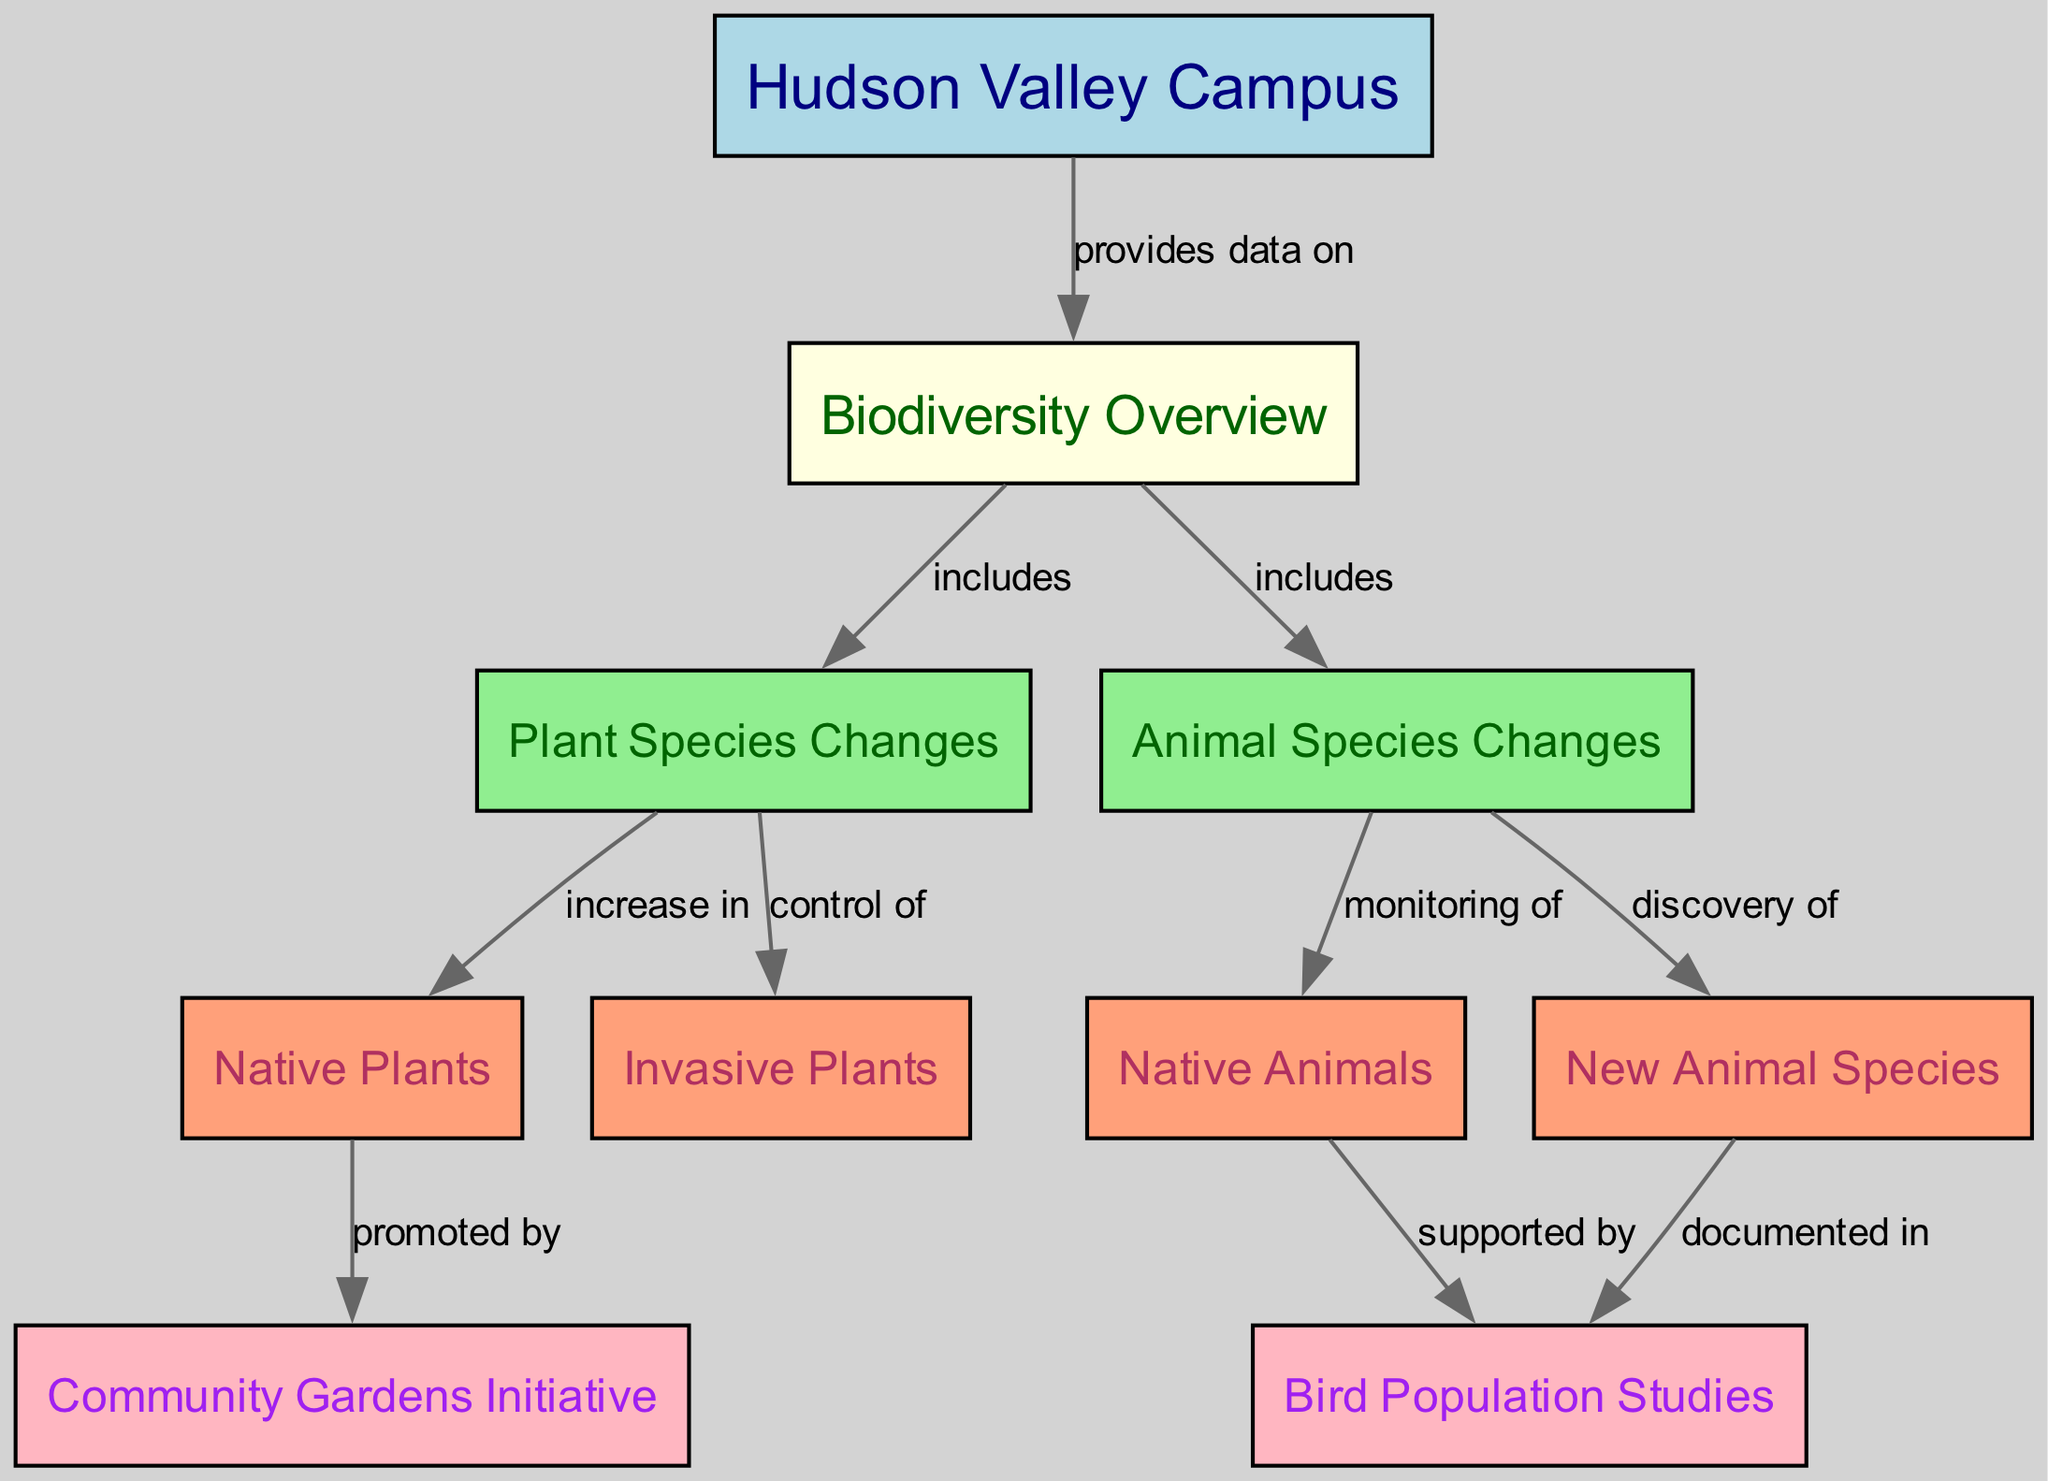What is the main topic of the diagram? The main topic of the diagram is represented by the first node, labeled "Hudson Valley Campus." This node connects to the overview of biodiversity, indicating that the diagram outlines the biodiversity at this campus.
Answer: Hudson Valley Campus How many nodes are there in total? By counting the nodes provided in the data, there are a total of 10 nodes, each representing different aspects of biodiversity and the campus.
Answer: 10 What does the Hudson Valley Campus provide data on? The edge connecting the "Hudson Valley Campus" node to the "Biodiversity Overview" node is labeled "provides data on," indicating the type of information shared by the campus.
Answer: Biodiversity Overview Which species are monitored according to the diagram? The relationship from the "Animal Species Changes" node to the "Native Animals" node is labeled "monitoring of," indicating that native animals are tracked and studied as part of the campus biodiversity efforts.
Answer: Native Animals What is promoted by native plants? The edge from the "Native Plants" node to the "Community Gardens Initiative" node is labeled "promoted by," meaning that the presence of native plants supports the establishment of community gardens on campus.
Answer: Community Gardens Initiative How are new animal species documented? The connection from the "New Animal Species" node to the "Bird Population Studies" node is labeled "documented in," indicating that the new species discovered are recorded through studies focused on bird populations.
Answer: Bird Population Studies How do invasive plants relate to the plant species changes? The "Plant Species Changes" node has an edge to the "Invasive Plants" node labeled "control of," suggesting that part of managing plant diversity involves controlling invasive plant species affecting the ecosystem.
Answer: Control of What supports the monitoring of native animals? The diagram indicates that the monitoring of native animals is supported by studies focused on bird populations, as described by the edge from "Native Animals" to "Bird Population Studies."
Answer: Bird Population Studies 